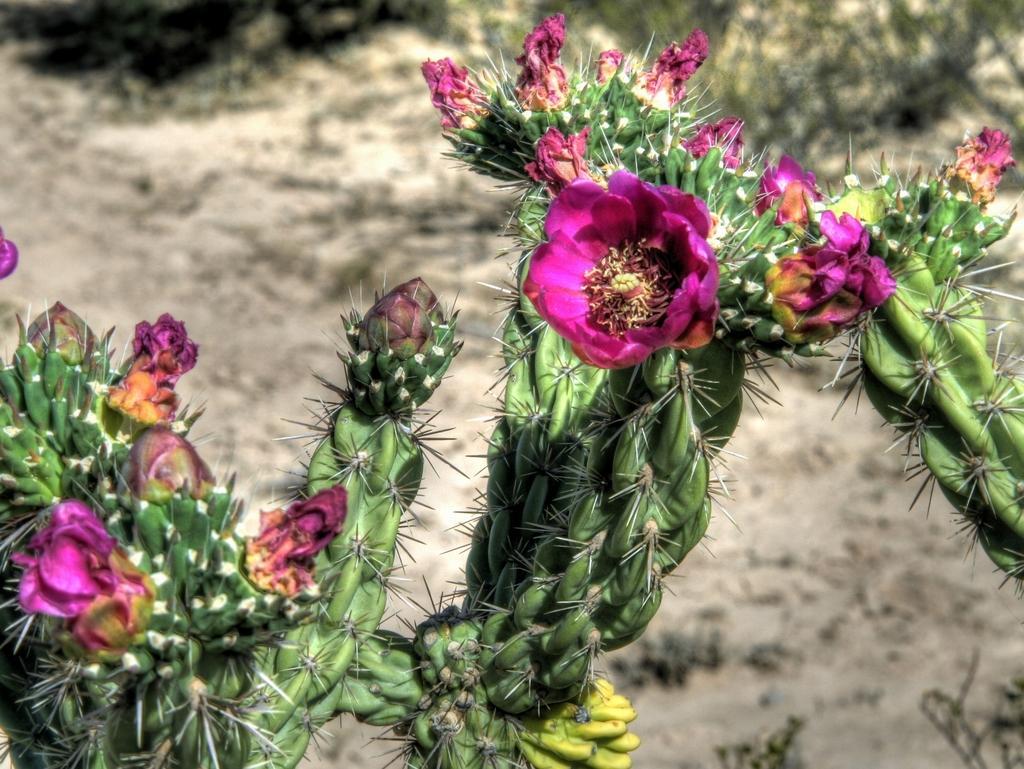How would you summarize this image in a sentence or two? In this image, I can see the cactus plants with flowers. There is a blurred background. 